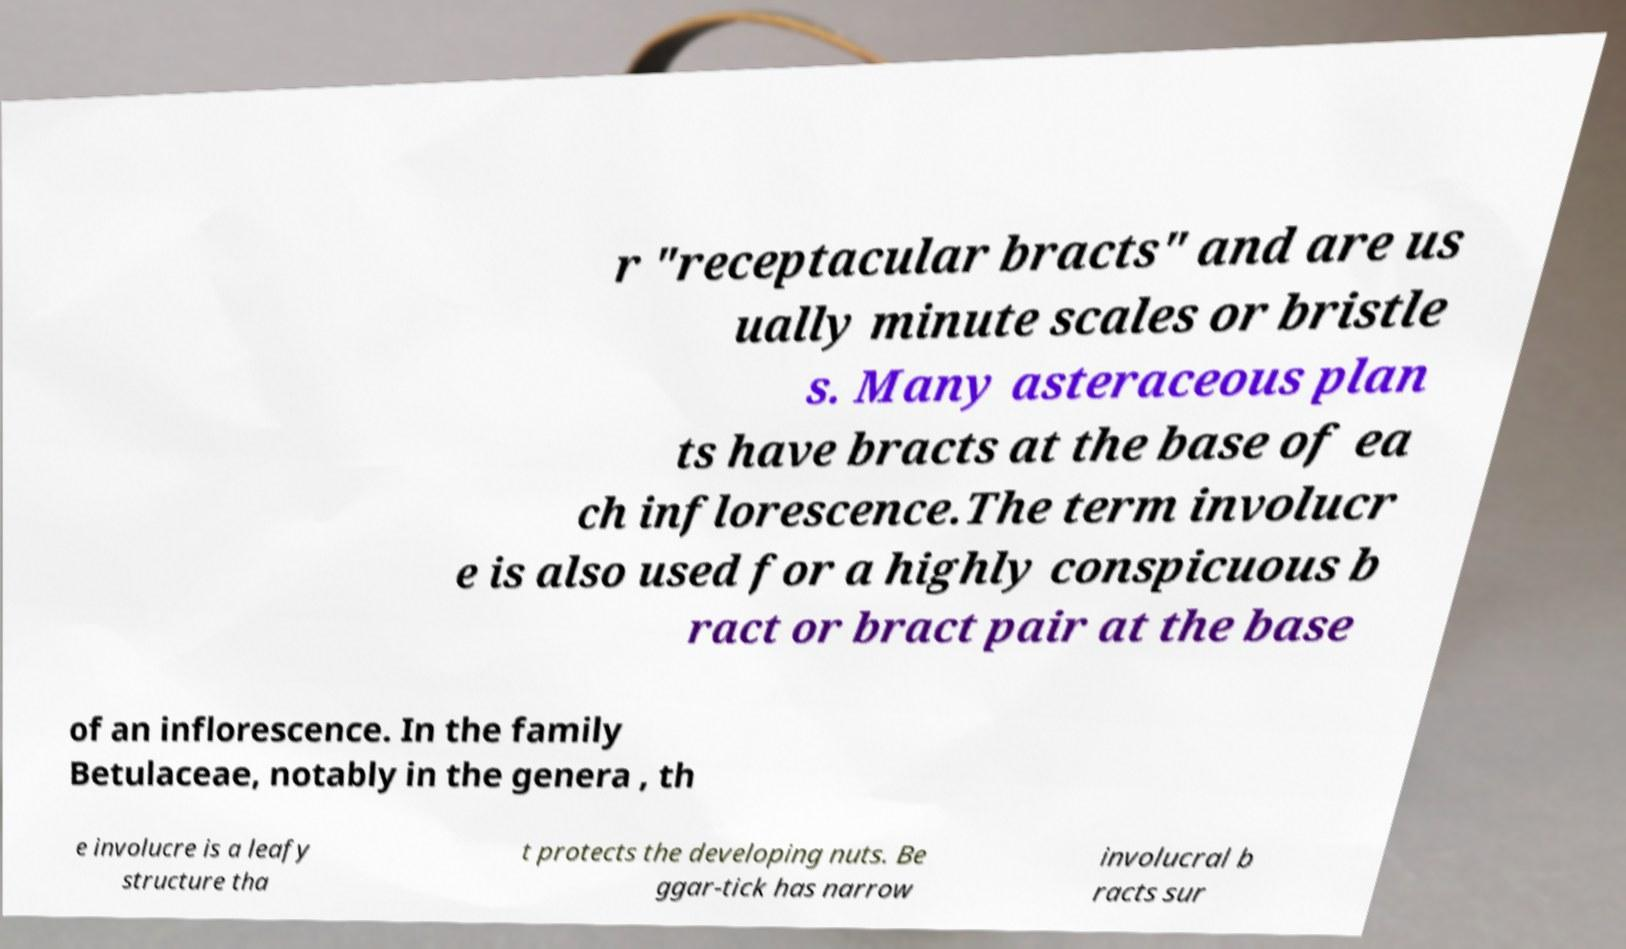Could you assist in decoding the text presented in this image and type it out clearly? r "receptacular bracts" and are us ually minute scales or bristle s. Many asteraceous plan ts have bracts at the base of ea ch inflorescence.The term involucr e is also used for a highly conspicuous b ract or bract pair at the base of an inflorescence. In the family Betulaceae, notably in the genera , th e involucre is a leafy structure tha t protects the developing nuts. Be ggar-tick has narrow involucral b racts sur 